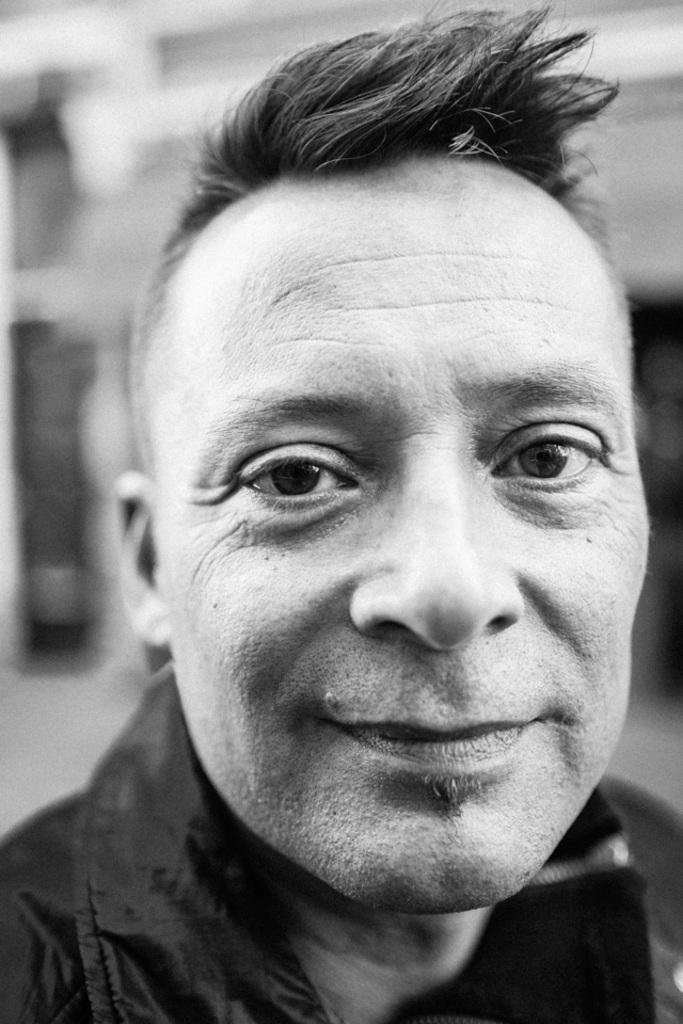What is the main subject in the foreground of the image? There is a man in the foreground of the image. Can you describe the background of the image? The background of the image is blurred. What type of tank is visible in the image? There is no tank present in the image. On what throne is the man sitting in the image? There is no throne present in the image. 